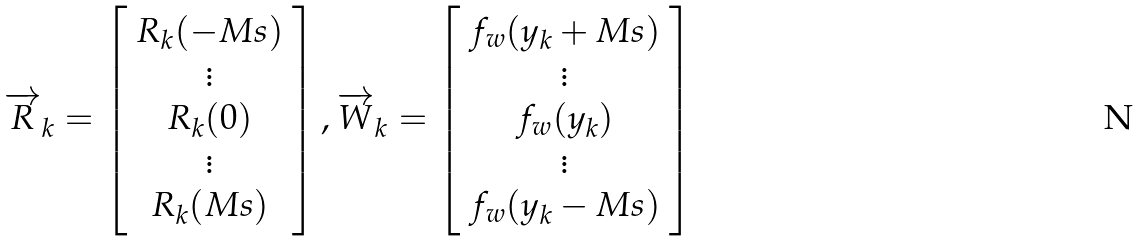Convert formula to latex. <formula><loc_0><loc_0><loc_500><loc_500>\overrightarrow { R } _ { k } = \left [ \begin{array} { c } R _ { k } ( - M s ) \\ \vdots \\ R _ { k } ( 0 ) \\ \vdots \\ R _ { k } ( M s ) \end{array} \right ] , \overrightarrow { W } _ { k } = \left [ \begin{array} { c } f _ { w } ( y _ { k } + M s ) \\ \vdots \\ f _ { w } ( y _ { k } ) \\ \vdots \\ f _ { w } ( y _ { k } - M s ) \end{array} \right ]</formula> 